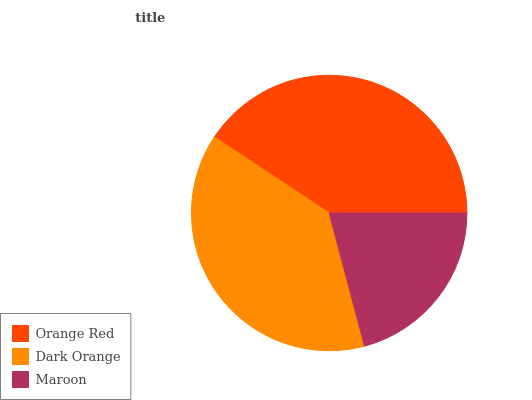Is Maroon the minimum?
Answer yes or no. Yes. Is Orange Red the maximum?
Answer yes or no. Yes. Is Dark Orange the minimum?
Answer yes or no. No. Is Dark Orange the maximum?
Answer yes or no. No. Is Orange Red greater than Dark Orange?
Answer yes or no. Yes. Is Dark Orange less than Orange Red?
Answer yes or no. Yes. Is Dark Orange greater than Orange Red?
Answer yes or no. No. Is Orange Red less than Dark Orange?
Answer yes or no. No. Is Dark Orange the high median?
Answer yes or no. Yes. Is Dark Orange the low median?
Answer yes or no. Yes. Is Maroon the high median?
Answer yes or no. No. Is Orange Red the low median?
Answer yes or no. No. 